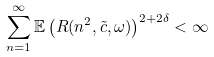Convert formula to latex. <formula><loc_0><loc_0><loc_500><loc_500>\sum _ { n = 1 } ^ { \infty } \mathbb { E } \left ( R ( n ^ { 2 } , \tilde { c } , \omega ) \right ) ^ { 2 + 2 \delta } < \infty</formula> 